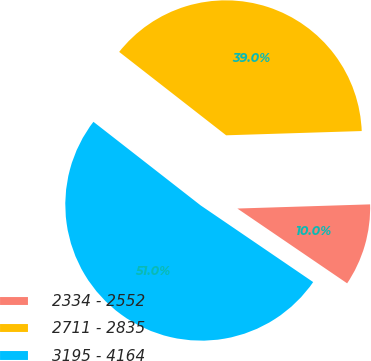Convert chart. <chart><loc_0><loc_0><loc_500><loc_500><pie_chart><fcel>2334 - 2552<fcel>2711 - 2835<fcel>3195 - 4164<nl><fcel>10.02%<fcel>38.96%<fcel>51.02%<nl></chart> 